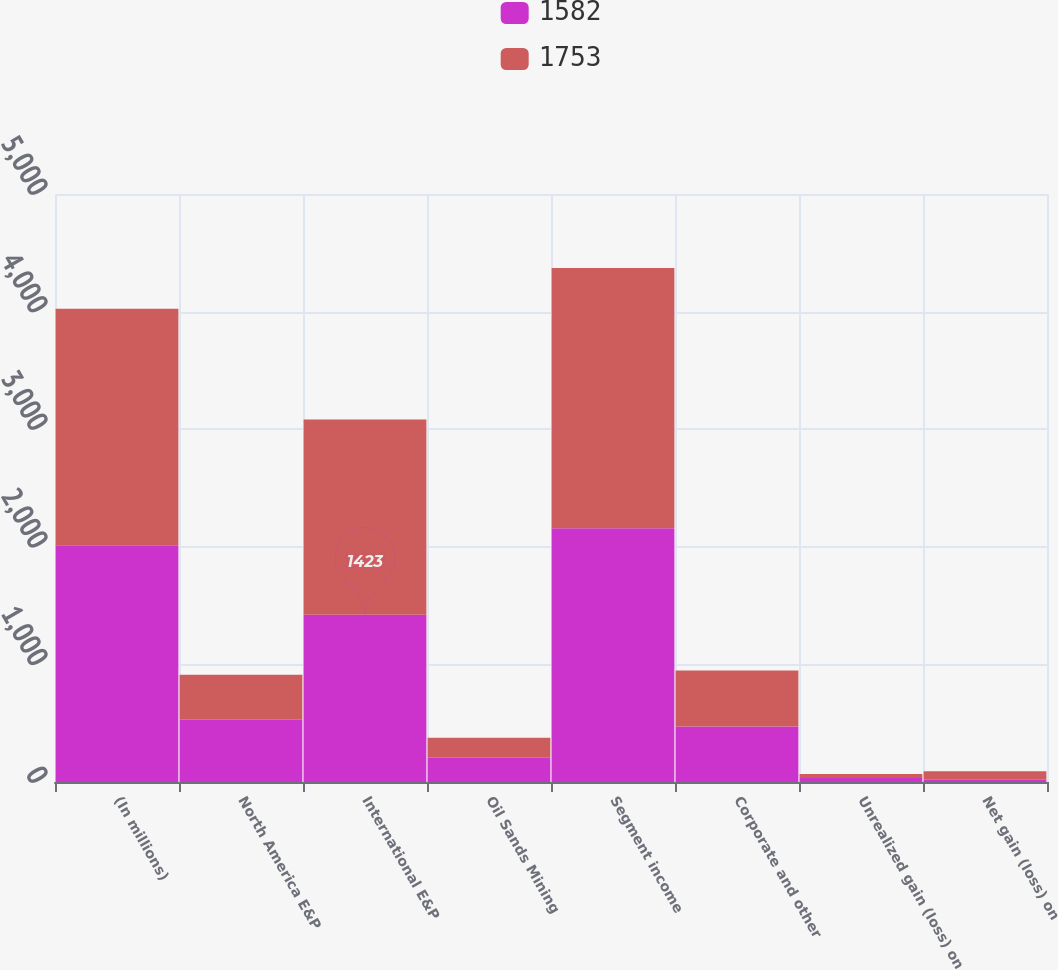<chart> <loc_0><loc_0><loc_500><loc_500><stacked_bar_chart><ecel><fcel>(In millions)<fcel>North America E&P<fcel>International E&P<fcel>Oil Sands Mining<fcel>Segment income<fcel>Corporate and other<fcel>Unrealized gain (loss) on<fcel>Net gain (loss) on<nl><fcel>1582<fcel>2013<fcel>529<fcel>1423<fcel>206<fcel>2158<fcel>473<fcel>33<fcel>20<nl><fcel>1753<fcel>2012<fcel>382<fcel>1660<fcel>171<fcel>2213<fcel>475<fcel>34<fcel>72<nl></chart> 